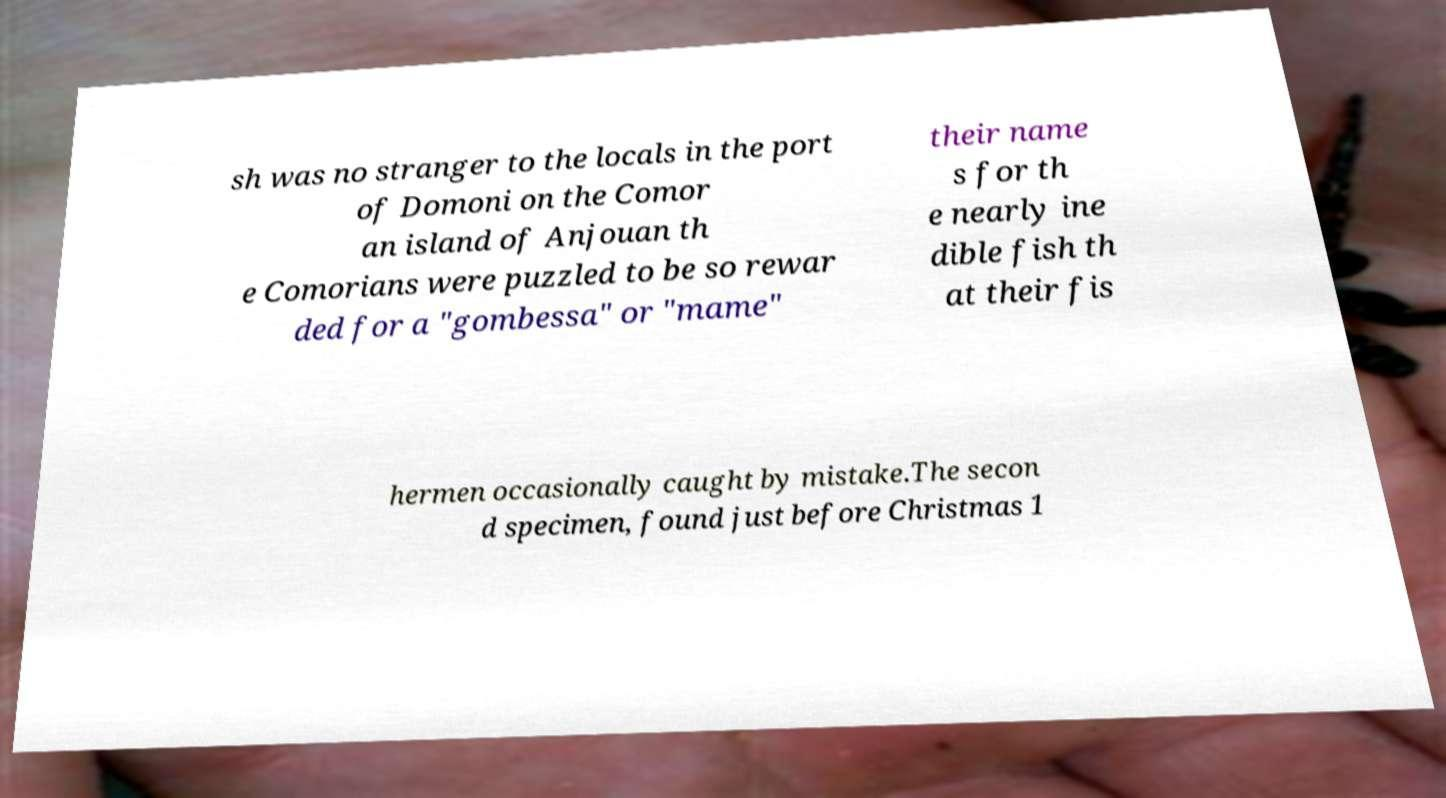Can you accurately transcribe the text from the provided image for me? sh was no stranger to the locals in the port of Domoni on the Comor an island of Anjouan th e Comorians were puzzled to be so rewar ded for a "gombessa" or "mame" their name s for th e nearly ine dible fish th at their fis hermen occasionally caught by mistake.The secon d specimen, found just before Christmas 1 